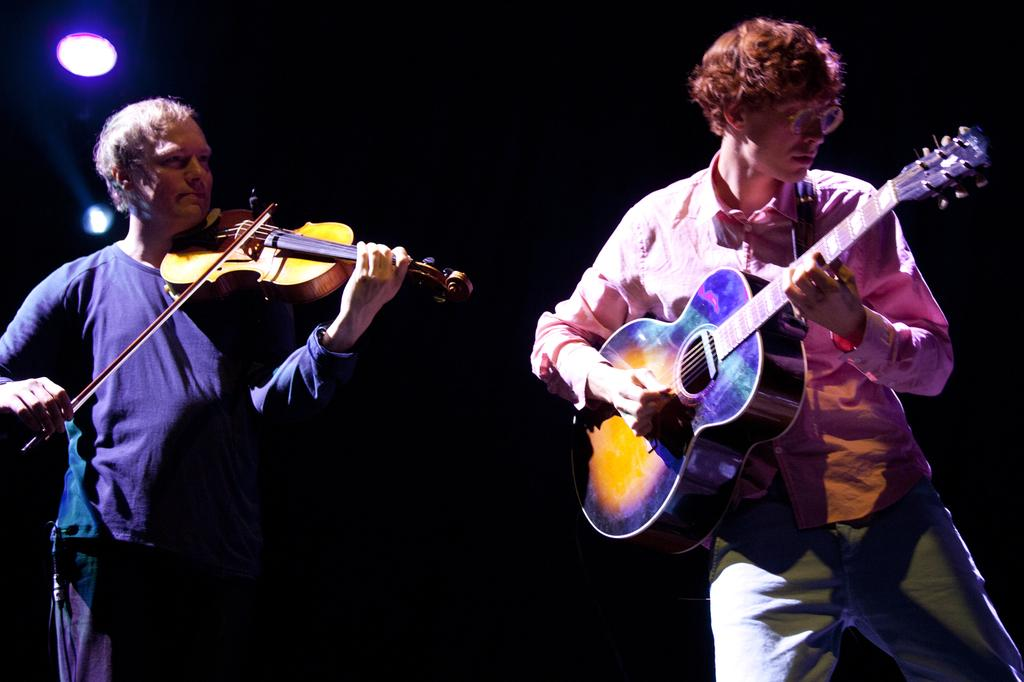How many people are in the image? There are two men in the image. What are the men doing in the image? Both men are holding musical instruments. Can you describe the actions of each man? One man is playing a guitar, and the other man is playing a violin. How many kittens are being pulled by the men in the image? There are no kittens present in the image, and the men are not pulling anything. 